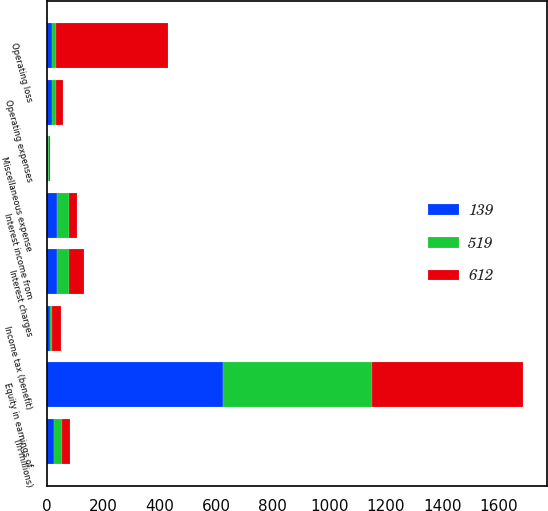<chart> <loc_0><loc_0><loc_500><loc_500><stacked_bar_chart><ecel><fcel>(In millions)<fcel>Operating expenses<fcel>Operating loss<fcel>Equity in earnings of<fcel>Interest income from<fcel>Miscellaneous expense<fcel>Interest charges<fcel>Income tax (benefit)<nl><fcel>519<fcel>28<fcel>15<fcel>15<fcel>527<fcel>44<fcel>4<fcel>41<fcel>8<nl><fcel>612<fcel>28<fcel>24<fcel>396<fcel>535<fcel>28<fcel>3<fcel>56<fcel>31<nl><fcel>139<fcel>28<fcel>20<fcel>20<fcel>625<fcel>36<fcel>4<fcel>37<fcel>12<nl></chart> 